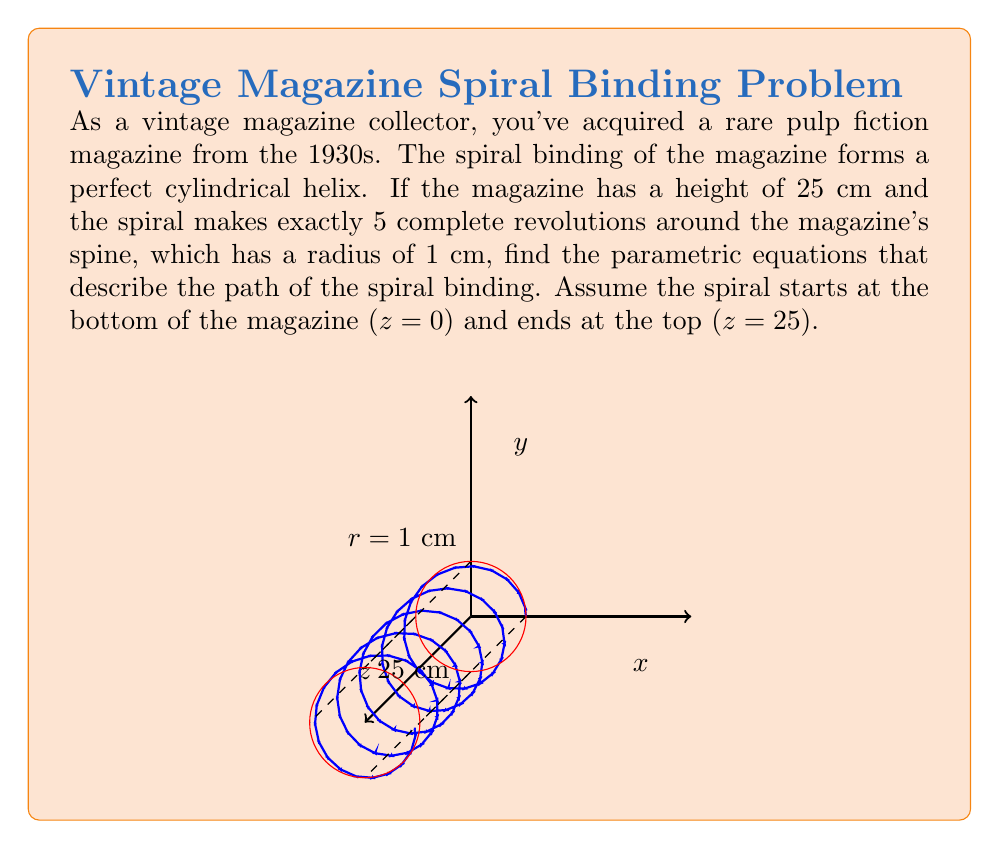What is the answer to this math problem? Let's approach this step-by-step:

1) In a cylindrical helix, the x and y coordinates are described by circular motion, while the z coordinate increases linearly with the angle of rotation.

2) The parametric equations for a helix are generally of the form:
   $$x = r \cos(t)$$
   $$y = r \sin(t)$$
   $$z = ct$$
   where $r$ is the radius of the cylinder, $t$ is the parameter (angle of rotation), and $c$ is a constant that determines the "pitch" of the helix.

3) We know:
   - The radius $r = 1$ cm
   - The height of the magazine is 25 cm
   - The spiral makes 5 complete revolutions

4) One complete revolution corresponds to $2\pi$ radians. So, when $t$ goes from 0 to $10\pi$ (5 complete revolutions), z should go from 0 to 25.

5) We can find $c$ by setting up the equation:
   $$25 = c(10\pi)$$
   $$c = \frac{25}{10\pi} = \frac{5}{2\pi}$$

6) Therefore, our parametric equations are:
   $$x = \cos(t)$$
   $$y = \sin(t)$$
   $$z = \frac{5}{2\pi}t$$

7) The domain for $t$ is $[0, 10\pi]$, representing the 5 complete revolutions from bottom to top of the magazine.
Answer: $x = \cos(t)$, $y = \sin(t)$, $z = \frac{5}{2\pi}t$, where $0 \leq t \leq 10\pi$ 